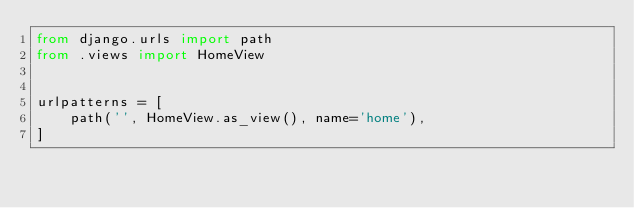<code> <loc_0><loc_0><loc_500><loc_500><_Python_>from django.urls import path
from .views import HomeView


urlpatterns = [
    path('', HomeView.as_view(), name='home'),
]
</code> 